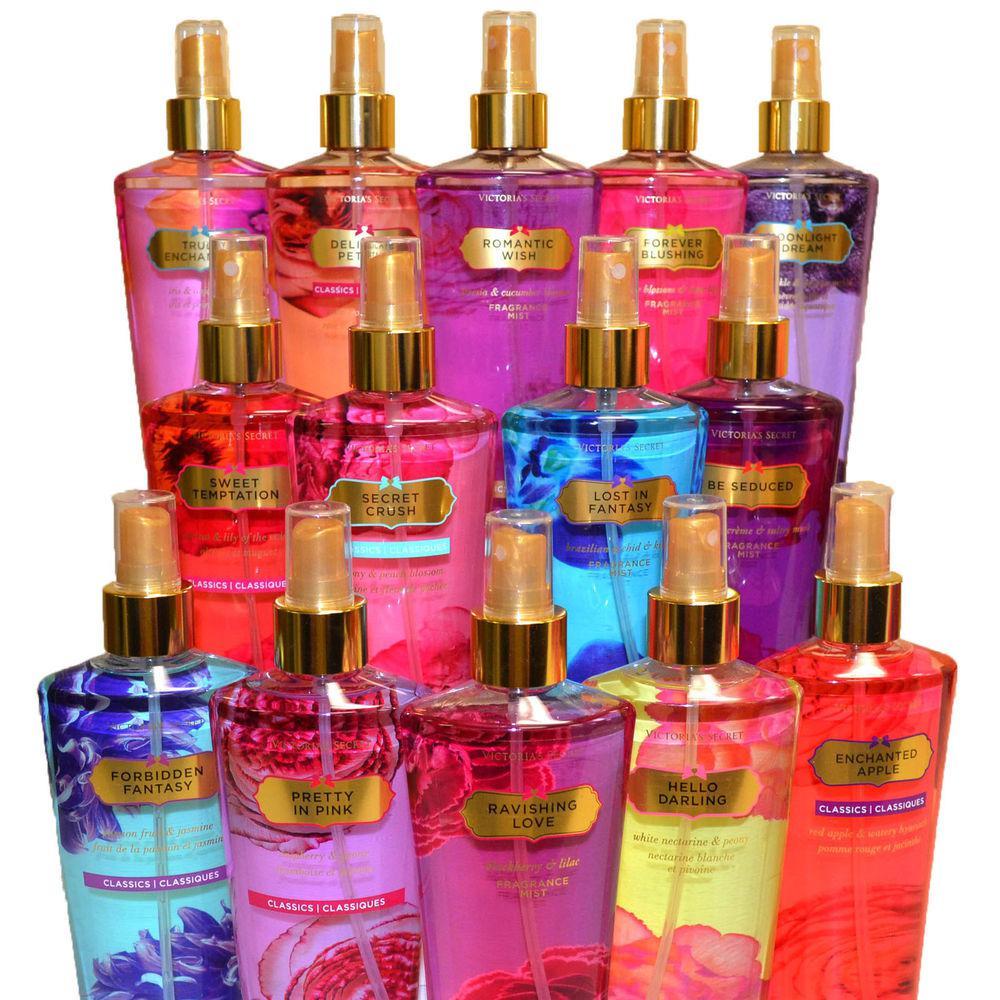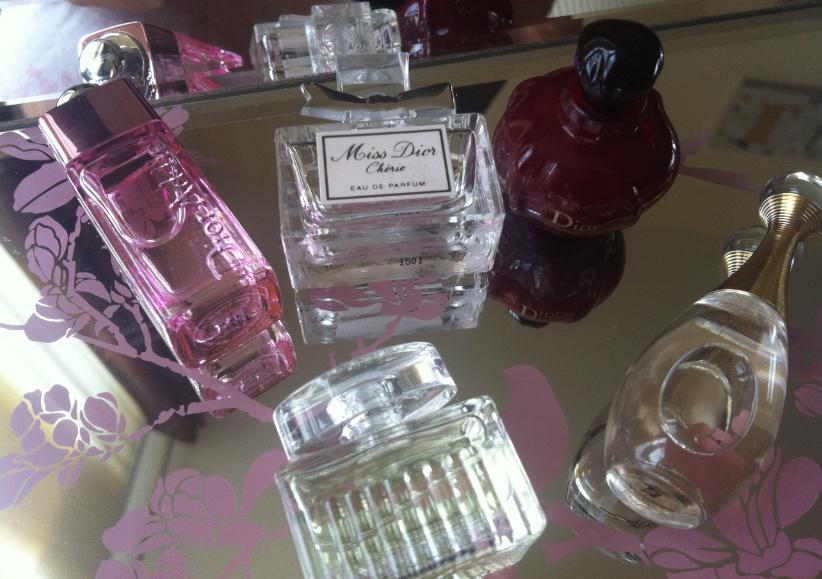The first image is the image on the left, the second image is the image on the right. Assess this claim about the two images: "The left image includes a horizontal row of at least five bottles of the same size and shape, but in different fragrance varieties.". Correct or not? Answer yes or no. Yes. The first image is the image on the left, the second image is the image on the right. Evaluate the accuracy of this statement regarding the images: "A person is holding a product.". Is it true? Answer yes or no. No. 